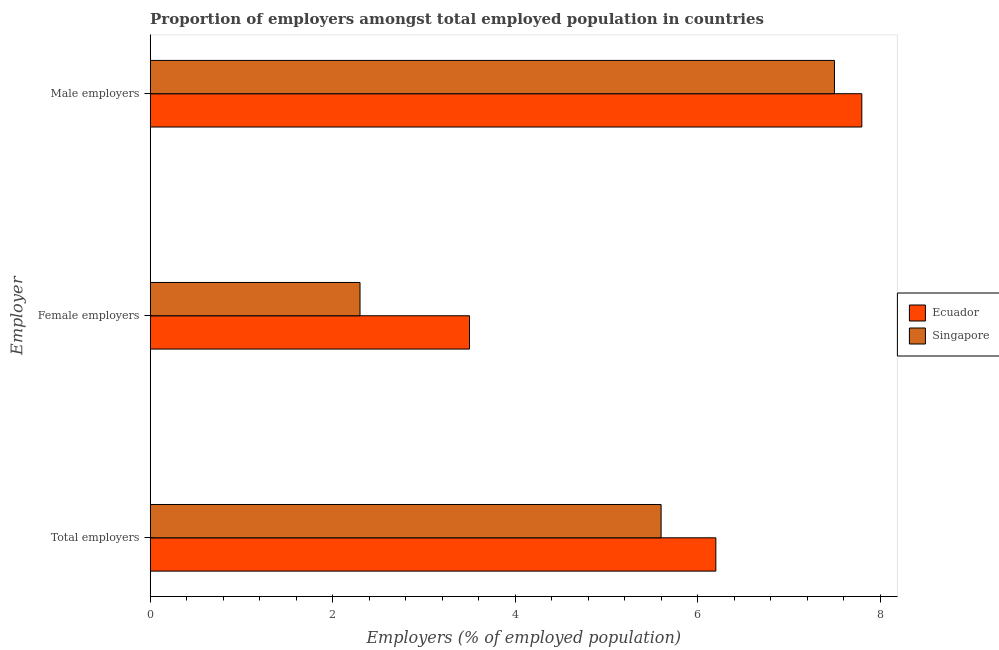How many different coloured bars are there?
Give a very brief answer. 2. How many groups of bars are there?
Your response must be concise. 3. Are the number of bars on each tick of the Y-axis equal?
Ensure brevity in your answer.  Yes. How many bars are there on the 1st tick from the bottom?
Your answer should be very brief. 2. What is the label of the 3rd group of bars from the top?
Provide a short and direct response. Total employers. What is the percentage of female employers in Ecuador?
Ensure brevity in your answer.  3.5. Across all countries, what is the maximum percentage of male employers?
Your answer should be compact. 7.8. Across all countries, what is the minimum percentage of male employers?
Offer a very short reply. 7.5. In which country was the percentage of female employers maximum?
Offer a terse response. Ecuador. In which country was the percentage of female employers minimum?
Keep it short and to the point. Singapore. What is the total percentage of total employers in the graph?
Make the answer very short. 11.8. What is the difference between the percentage of female employers in Singapore and that in Ecuador?
Offer a terse response. -1.2. What is the difference between the percentage of total employers in Singapore and the percentage of female employers in Ecuador?
Ensure brevity in your answer.  2.1. What is the average percentage of total employers per country?
Offer a very short reply. 5.9. What is the difference between the percentage of female employers and percentage of male employers in Singapore?
Make the answer very short. -5.2. In how many countries, is the percentage of male employers greater than 3.2 %?
Your answer should be very brief. 2. What is the ratio of the percentage of total employers in Ecuador to that in Singapore?
Ensure brevity in your answer.  1.11. Is the percentage of total employers in Ecuador less than that in Singapore?
Offer a terse response. No. What is the difference between the highest and the second highest percentage of male employers?
Ensure brevity in your answer.  0.3. What is the difference between the highest and the lowest percentage of female employers?
Provide a short and direct response. 1.2. In how many countries, is the percentage of female employers greater than the average percentage of female employers taken over all countries?
Offer a very short reply. 1. What does the 1st bar from the top in Male employers represents?
Your response must be concise. Singapore. What does the 1st bar from the bottom in Female employers represents?
Ensure brevity in your answer.  Ecuador. Is it the case that in every country, the sum of the percentage of total employers and percentage of female employers is greater than the percentage of male employers?
Provide a succinct answer. Yes. How many bars are there?
Give a very brief answer. 6. Are all the bars in the graph horizontal?
Keep it short and to the point. Yes. How many countries are there in the graph?
Provide a short and direct response. 2. Does the graph contain grids?
Provide a succinct answer. No. Where does the legend appear in the graph?
Provide a succinct answer. Center right. How are the legend labels stacked?
Give a very brief answer. Vertical. What is the title of the graph?
Provide a short and direct response. Proportion of employers amongst total employed population in countries. Does "Jamaica" appear as one of the legend labels in the graph?
Your response must be concise. No. What is the label or title of the X-axis?
Give a very brief answer. Employers (% of employed population). What is the label or title of the Y-axis?
Provide a succinct answer. Employer. What is the Employers (% of employed population) of Ecuador in Total employers?
Your answer should be very brief. 6.2. What is the Employers (% of employed population) in Singapore in Total employers?
Offer a very short reply. 5.6. What is the Employers (% of employed population) in Ecuador in Female employers?
Your answer should be compact. 3.5. What is the Employers (% of employed population) of Singapore in Female employers?
Your answer should be very brief. 2.3. What is the Employers (% of employed population) in Ecuador in Male employers?
Provide a short and direct response. 7.8. What is the Employers (% of employed population) in Singapore in Male employers?
Your answer should be compact. 7.5. Across all Employer, what is the maximum Employers (% of employed population) in Ecuador?
Ensure brevity in your answer.  7.8. Across all Employer, what is the minimum Employers (% of employed population) of Singapore?
Provide a short and direct response. 2.3. What is the total Employers (% of employed population) of Singapore in the graph?
Ensure brevity in your answer.  15.4. What is the difference between the Employers (% of employed population) in Ecuador in Total employers and that in Male employers?
Make the answer very short. -1.6. What is the difference between the Employers (% of employed population) of Singapore in Total employers and that in Male employers?
Keep it short and to the point. -1.9. What is the difference between the Employers (% of employed population) in Ecuador in Female employers and that in Male employers?
Keep it short and to the point. -4.3. What is the difference between the Employers (% of employed population) in Ecuador in Total employers and the Employers (% of employed population) in Singapore in Female employers?
Give a very brief answer. 3.9. What is the average Employers (% of employed population) of Ecuador per Employer?
Keep it short and to the point. 5.83. What is the average Employers (% of employed population) in Singapore per Employer?
Ensure brevity in your answer.  5.13. What is the difference between the Employers (% of employed population) in Ecuador and Employers (% of employed population) in Singapore in Total employers?
Your response must be concise. 0.6. What is the difference between the Employers (% of employed population) of Ecuador and Employers (% of employed population) of Singapore in Female employers?
Provide a short and direct response. 1.2. What is the ratio of the Employers (% of employed population) of Ecuador in Total employers to that in Female employers?
Your answer should be very brief. 1.77. What is the ratio of the Employers (% of employed population) of Singapore in Total employers to that in Female employers?
Make the answer very short. 2.43. What is the ratio of the Employers (% of employed population) of Ecuador in Total employers to that in Male employers?
Provide a short and direct response. 0.79. What is the ratio of the Employers (% of employed population) of Singapore in Total employers to that in Male employers?
Your response must be concise. 0.75. What is the ratio of the Employers (% of employed population) of Ecuador in Female employers to that in Male employers?
Keep it short and to the point. 0.45. What is the ratio of the Employers (% of employed population) of Singapore in Female employers to that in Male employers?
Provide a succinct answer. 0.31. What is the difference between the highest and the lowest Employers (% of employed population) in Singapore?
Offer a terse response. 5.2. 